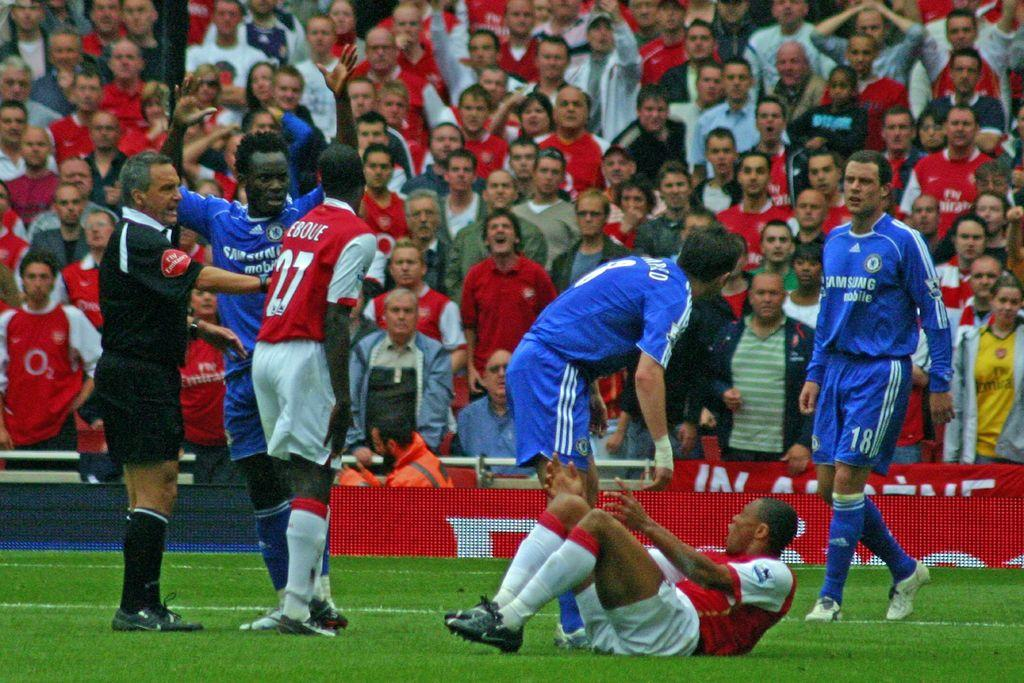<image>
Provide a brief description of the given image. The player in the red 27 jersey argues with a player of the opposite team. 